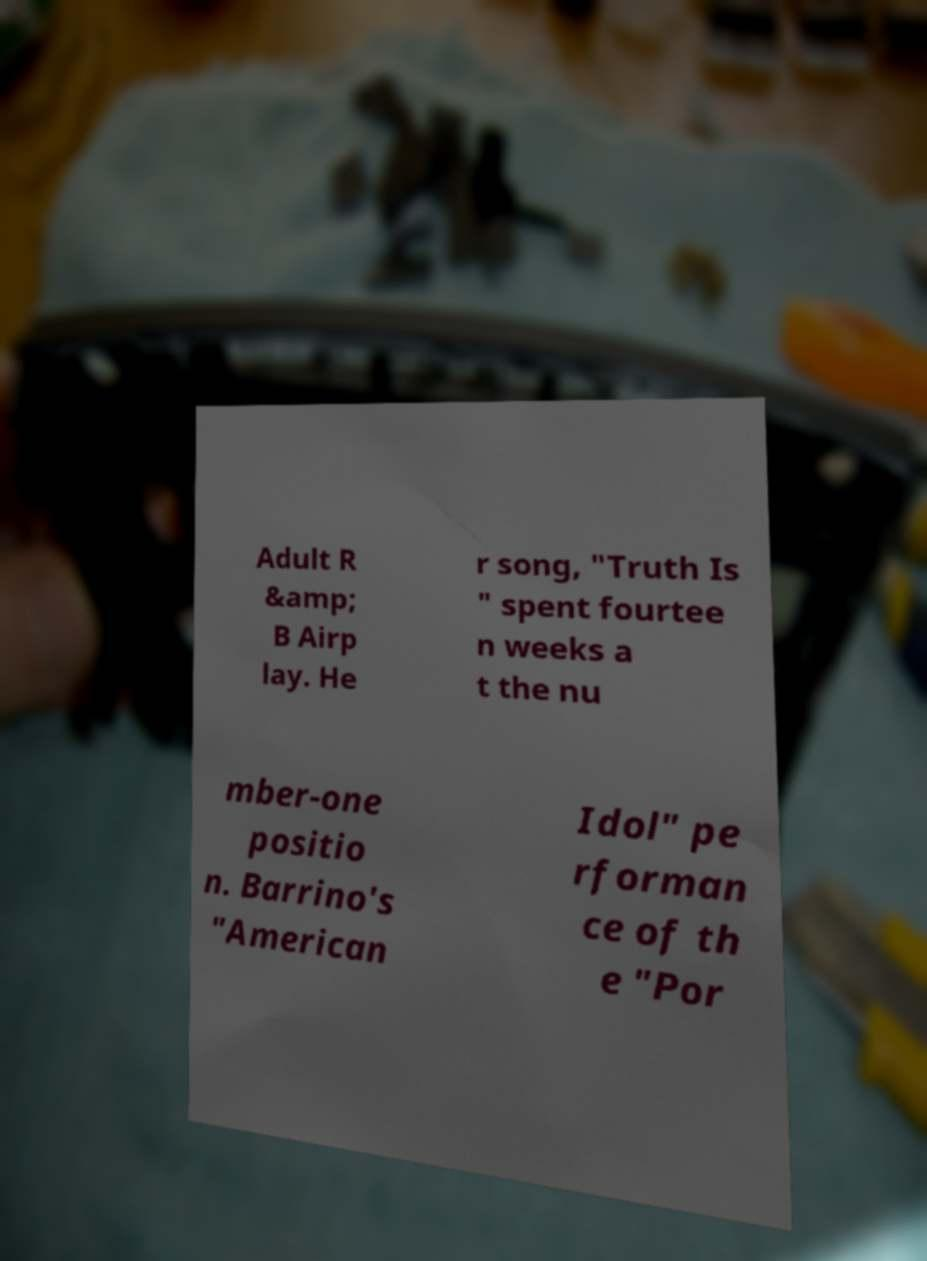Can you accurately transcribe the text from the provided image for me? Adult R &amp; B Airp lay. He r song, "Truth Is " spent fourtee n weeks a t the nu mber-one positio n. Barrino's "American Idol" pe rforman ce of th e "Por 